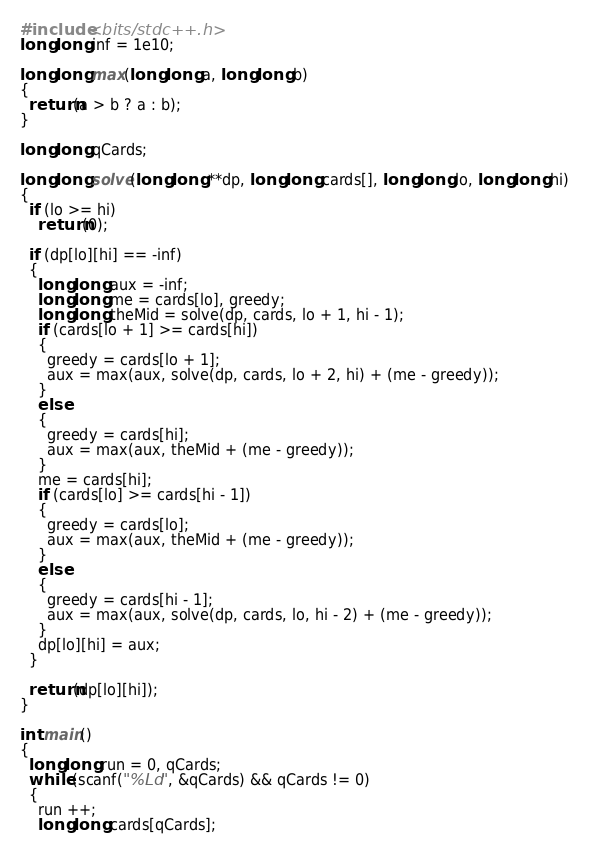Convert code to text. <code><loc_0><loc_0><loc_500><loc_500><_C++_>#include <bits/stdc++.h>
long long inf = 1e10;

long long max(long long a, long long b)
{
  return(a > b ? a : b);
}

long long qCards;

long long solve(long long **dp, long long cards[], long long lo, long long hi)
{
  if (lo >= hi)
    return(0);

  if (dp[lo][hi] == -inf)
  {
    long long aux = -inf;
    long long me = cards[lo], greedy;
    long long theMid = solve(dp, cards, lo + 1, hi - 1);
    if (cards[lo + 1] >= cards[hi])
    {
      greedy = cards[lo + 1];
      aux = max(aux, solve(dp, cards, lo + 2, hi) + (me - greedy));
    }
    else
    {
      greedy = cards[hi];
      aux = max(aux, theMid + (me - greedy));
    }
    me = cards[hi];
    if (cards[lo] >= cards[hi - 1])
    {
      greedy = cards[lo];
      aux = max(aux, theMid + (me - greedy));
    }
    else
    {
      greedy = cards[hi - 1];
      aux = max(aux, solve(dp, cards, lo, hi - 2) + (me - greedy));
    }
    dp[lo][hi] = aux;
  }

  return(dp[lo][hi]);
}

int main()
{
  long long run = 0, qCards;
  while (scanf("%Ld", &qCards) && qCards != 0)
  {
    run ++;
    long long cards[qCards];</code> 